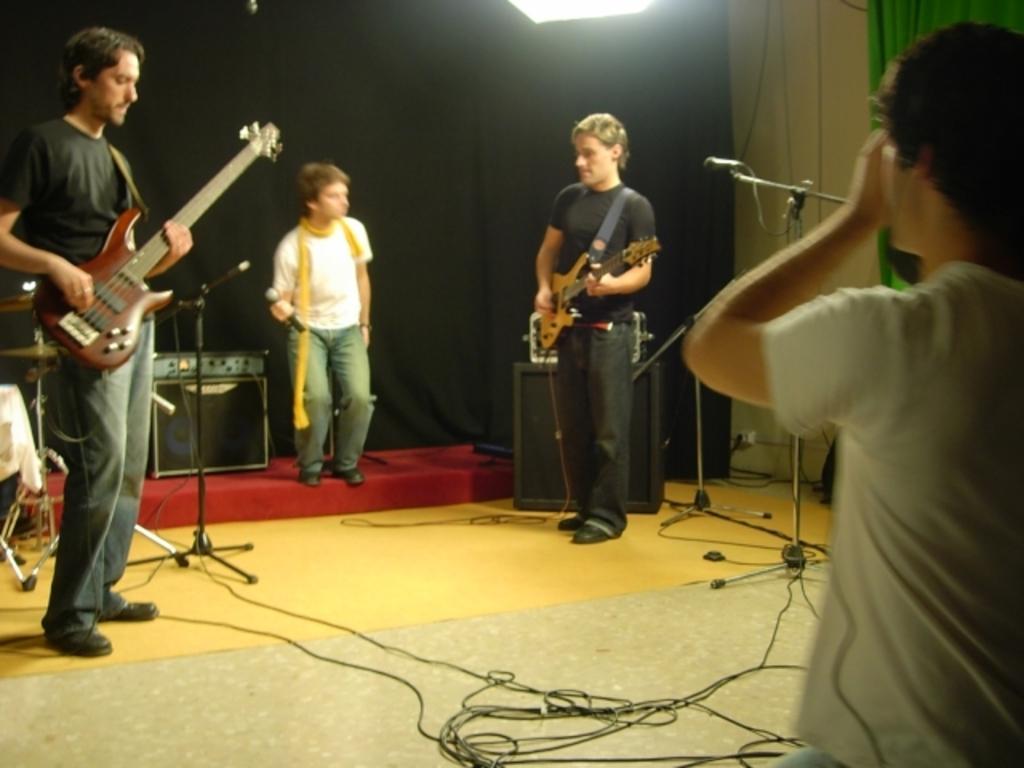How would you summarize this image in a sentence or two? It is a music show there are four people in the picture, two of them are playing guitar one person is singing a song,in the background there are some music systems and a black color curtain. 